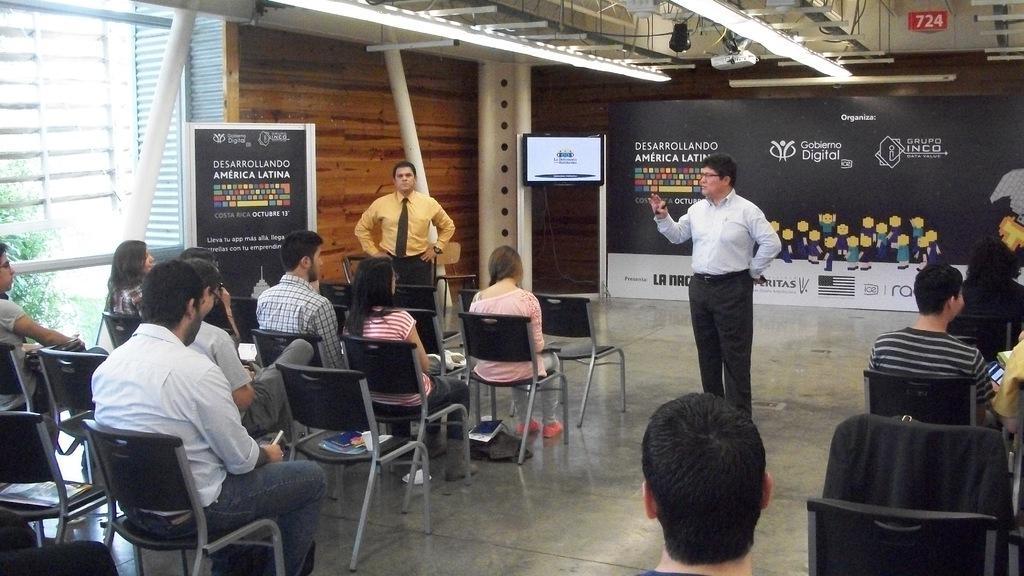Can you describe this image briefly? In this image there are a few people sitting on their chairs, in front of them there are two persons standing. In the background there is a screen and banner. At the top there is a ceiling with lights. 